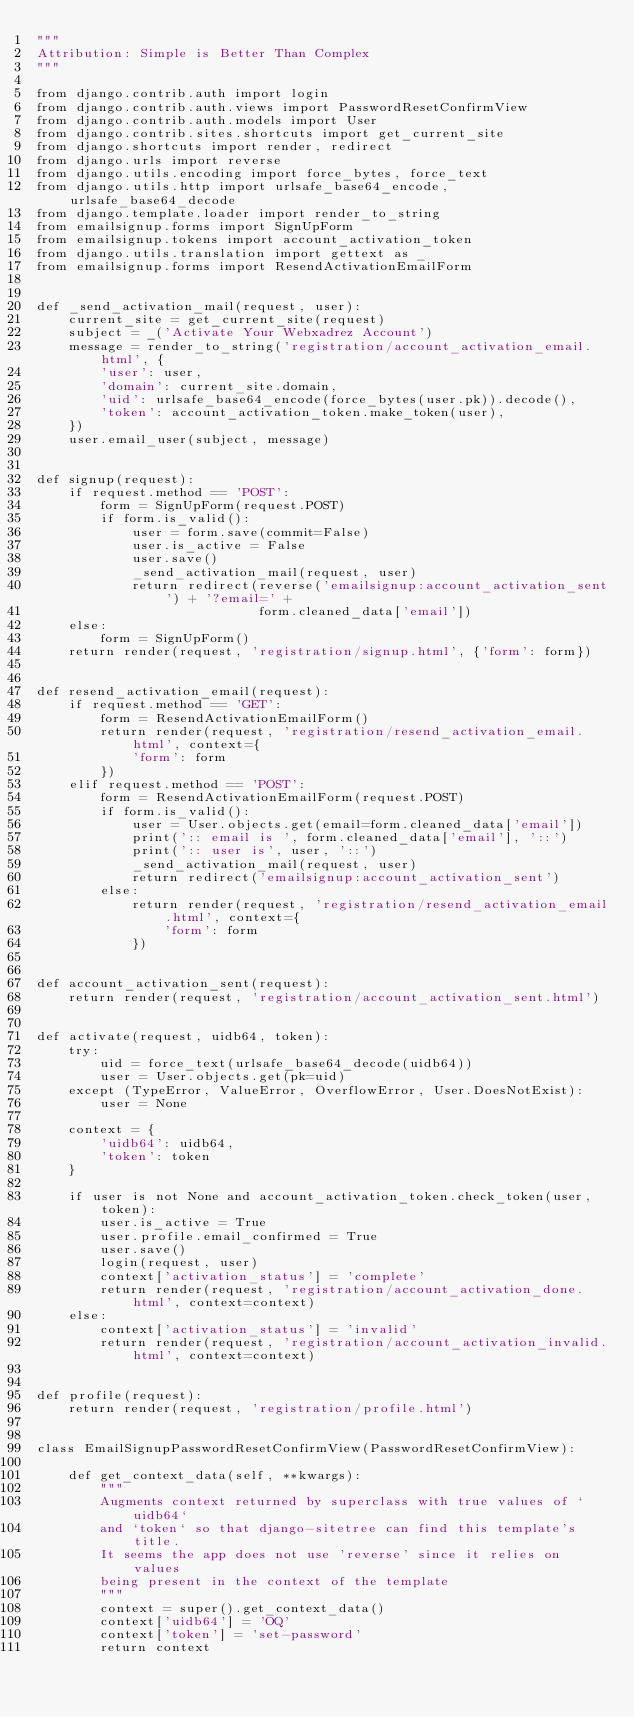<code> <loc_0><loc_0><loc_500><loc_500><_Python_>"""
Attribution: Simple is Better Than Complex
"""

from django.contrib.auth import login
from django.contrib.auth.views import PasswordResetConfirmView
from django.contrib.auth.models import User
from django.contrib.sites.shortcuts import get_current_site
from django.shortcuts import render, redirect
from django.urls import reverse
from django.utils.encoding import force_bytes, force_text
from django.utils.http import urlsafe_base64_encode, urlsafe_base64_decode
from django.template.loader import render_to_string
from emailsignup.forms import SignUpForm
from emailsignup.tokens import account_activation_token
from django.utils.translation import gettext as _
from emailsignup.forms import ResendActivationEmailForm


def _send_activation_mail(request, user):
    current_site = get_current_site(request)
    subject = _('Activate Your Webxadrez Account')
    message = render_to_string('registration/account_activation_email.html', {
        'user': user,
        'domain': current_site.domain,
        'uid': urlsafe_base64_encode(force_bytes(user.pk)).decode(),
        'token': account_activation_token.make_token(user),
    })
    user.email_user(subject, message)


def signup(request):
    if request.method == 'POST':
        form = SignUpForm(request.POST)
        if form.is_valid():
            user = form.save(commit=False)
            user.is_active = False
            user.save()
            _send_activation_mail(request, user)
            return redirect(reverse('emailsignup:account_activation_sent') + '?email=' +
                            form.cleaned_data['email'])
    else:
        form = SignUpForm()
    return render(request, 'registration/signup.html', {'form': form})


def resend_activation_email(request):
    if request.method == 'GET':
        form = ResendActivationEmailForm()
        return render(request, 'registration/resend_activation_email.html', context={
            'form': form
        })
    elif request.method == 'POST':
        form = ResendActivationEmailForm(request.POST)
        if form.is_valid():
            user = User.objects.get(email=form.cleaned_data['email'])
            print(':: email is ', form.cleaned_data['email'], '::')
            print(':: user is', user, '::')
            _send_activation_mail(request, user)
            return redirect('emailsignup:account_activation_sent')
        else:
            return render(request, 'registration/resend_activation_email.html', context={
                'form': form
            })


def account_activation_sent(request):
    return render(request, 'registration/account_activation_sent.html')


def activate(request, uidb64, token):
    try:
        uid = force_text(urlsafe_base64_decode(uidb64))
        user = User.objects.get(pk=uid)
    except (TypeError, ValueError, OverflowError, User.DoesNotExist):
        user = None

    context = {
        'uidb64': uidb64,
        'token': token
    }

    if user is not None and account_activation_token.check_token(user, token):
        user.is_active = True
        user.profile.email_confirmed = True
        user.save()
        login(request, user)
        context['activation_status'] = 'complete'
        return render(request, 'registration/account_activation_done.html', context=context)
    else:
        context['activation_status'] = 'invalid'
        return render(request, 'registration/account_activation_invalid.html', context=context)


def profile(request):
    return render(request, 'registration/profile.html')


class EmailSignupPasswordResetConfirmView(PasswordResetConfirmView):

    def get_context_data(self, **kwargs):
        """
        Augments context returned by superclass with true values of `uidb64`
        and `token` so that django-sitetree can find this template's title.
        It seems the app does not use 'reverse' since it relies on values
        being present in the context of the template
        """
        context = super().get_context_data()
        context['uidb64'] = 'OQ'
        context['token'] = 'set-password'
        return context
    </code> 